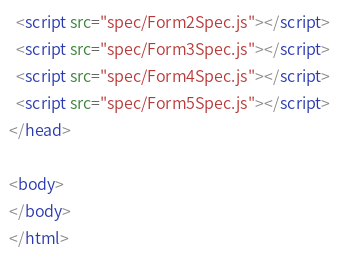<code> <loc_0><loc_0><loc_500><loc_500><_HTML_>  <script src="spec/Form2Spec.js"></script>
  <script src="spec/Form3Spec.js"></script>
  <script src="spec/Form4Spec.js"></script>
  <script src="spec/Form5Spec.js"></script>
</head>

<body>
</body>
</html>
</code> 